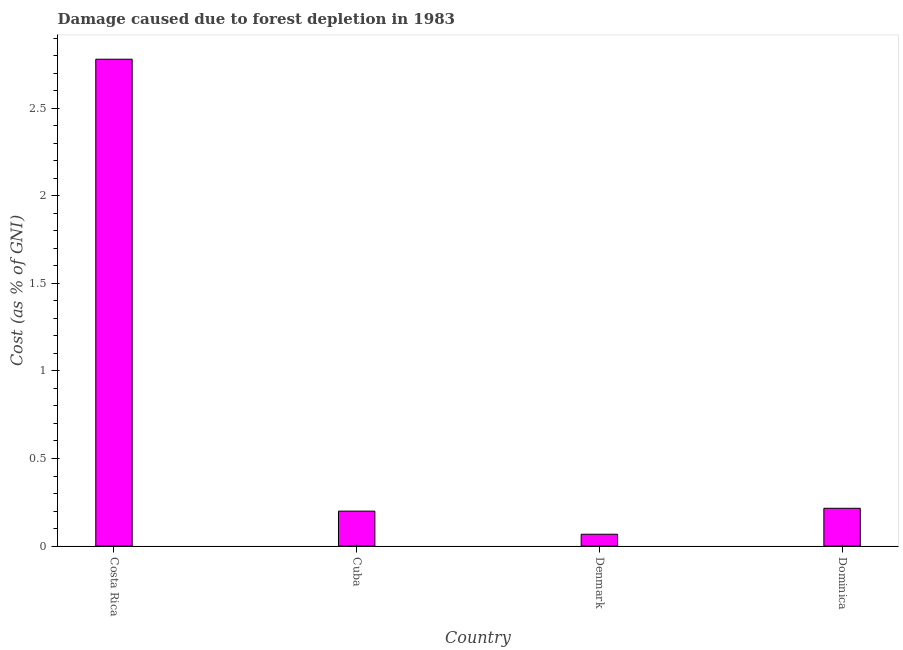Does the graph contain grids?
Your answer should be very brief. No. What is the title of the graph?
Offer a terse response. Damage caused due to forest depletion in 1983. What is the label or title of the X-axis?
Give a very brief answer. Country. What is the label or title of the Y-axis?
Your answer should be very brief. Cost (as % of GNI). What is the damage caused due to forest depletion in Dominica?
Make the answer very short. 0.22. Across all countries, what is the maximum damage caused due to forest depletion?
Ensure brevity in your answer.  2.78. Across all countries, what is the minimum damage caused due to forest depletion?
Your answer should be compact. 0.07. What is the sum of the damage caused due to forest depletion?
Provide a succinct answer. 3.26. What is the difference between the damage caused due to forest depletion in Cuba and Denmark?
Offer a very short reply. 0.13. What is the average damage caused due to forest depletion per country?
Provide a succinct answer. 0.82. What is the median damage caused due to forest depletion?
Provide a succinct answer. 0.21. What is the ratio of the damage caused due to forest depletion in Cuba to that in Dominica?
Your answer should be compact. 0.93. Is the difference between the damage caused due to forest depletion in Cuba and Denmark greater than the difference between any two countries?
Ensure brevity in your answer.  No. What is the difference between the highest and the second highest damage caused due to forest depletion?
Ensure brevity in your answer.  2.56. What is the difference between the highest and the lowest damage caused due to forest depletion?
Ensure brevity in your answer.  2.71. How many bars are there?
Your answer should be very brief. 4. Are all the bars in the graph horizontal?
Your answer should be very brief. No. How many countries are there in the graph?
Give a very brief answer. 4. What is the difference between two consecutive major ticks on the Y-axis?
Make the answer very short. 0.5. What is the Cost (as % of GNI) of Costa Rica?
Your answer should be very brief. 2.78. What is the Cost (as % of GNI) in Cuba?
Provide a succinct answer. 0.2. What is the Cost (as % of GNI) of Denmark?
Your answer should be compact. 0.07. What is the Cost (as % of GNI) of Dominica?
Keep it short and to the point. 0.22. What is the difference between the Cost (as % of GNI) in Costa Rica and Cuba?
Provide a succinct answer. 2.58. What is the difference between the Cost (as % of GNI) in Costa Rica and Denmark?
Offer a very short reply. 2.71. What is the difference between the Cost (as % of GNI) in Costa Rica and Dominica?
Ensure brevity in your answer.  2.56. What is the difference between the Cost (as % of GNI) in Cuba and Denmark?
Provide a short and direct response. 0.13. What is the difference between the Cost (as % of GNI) in Cuba and Dominica?
Your answer should be very brief. -0.02. What is the difference between the Cost (as % of GNI) in Denmark and Dominica?
Provide a succinct answer. -0.15. What is the ratio of the Cost (as % of GNI) in Costa Rica to that in Cuba?
Your answer should be very brief. 13.92. What is the ratio of the Cost (as % of GNI) in Costa Rica to that in Denmark?
Your response must be concise. 41.08. What is the ratio of the Cost (as % of GNI) in Costa Rica to that in Dominica?
Your response must be concise. 12.88. What is the ratio of the Cost (as % of GNI) in Cuba to that in Denmark?
Your answer should be compact. 2.95. What is the ratio of the Cost (as % of GNI) in Cuba to that in Dominica?
Give a very brief answer. 0.93. What is the ratio of the Cost (as % of GNI) in Denmark to that in Dominica?
Your response must be concise. 0.31. 